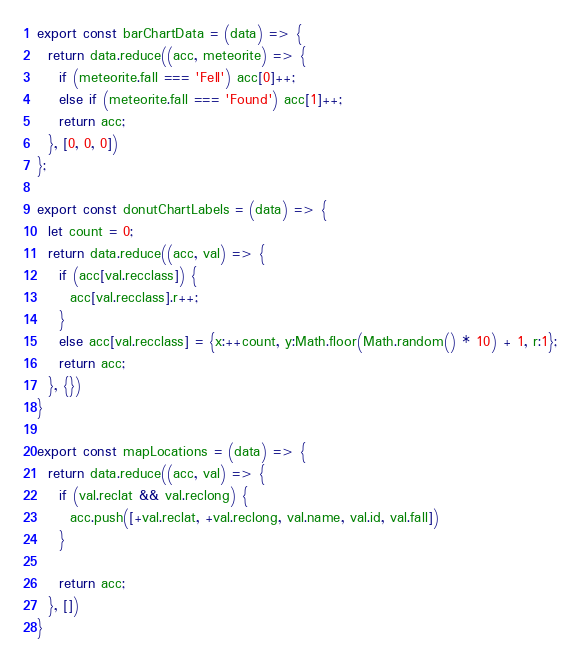<code> <loc_0><loc_0><loc_500><loc_500><_JavaScript_>export const barChartData = (data) => {
  return data.reduce((acc, meteorite) => {
    if (meteorite.fall === 'Fell') acc[0]++;
    else if (meteorite.fall === 'Found') acc[1]++;
    return acc;
  }, [0, 0, 0])
};

export const donutChartLabels = (data) => {
  let count = 0;
  return data.reduce((acc, val) => {
    if (acc[val.recclass]) {
      acc[val.recclass].r++;
    }
    else acc[val.recclass] = {x:++count, y:Math.floor(Math.random() * 10) + 1, r:1};
    return acc;
  }, {})
}

export const mapLocations = (data) => {
  return data.reduce((acc, val) => {
    if (val.reclat && val.reclong) {
      acc.push([+val.reclat, +val.reclong, val.name, val.id, val.fall])
    }

    return acc;
  }, [])
}
</code> 